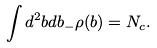<formula> <loc_0><loc_0><loc_500><loc_500>\int d ^ { 2 } b d b _ { - } \rho ( b ) = N _ { c } .</formula> 